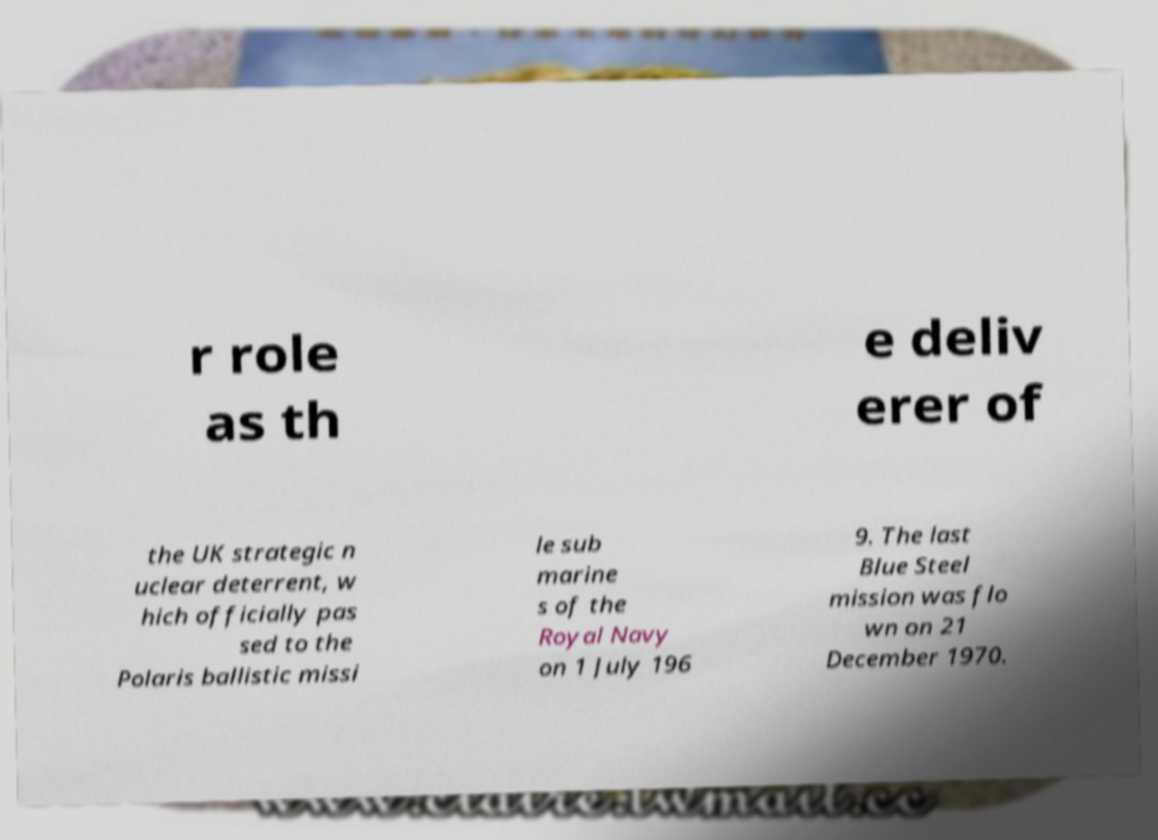Can you read and provide the text displayed in the image?This photo seems to have some interesting text. Can you extract and type it out for me? r role as th e deliv erer of the UK strategic n uclear deterrent, w hich officially pas sed to the Polaris ballistic missi le sub marine s of the Royal Navy on 1 July 196 9. The last Blue Steel mission was flo wn on 21 December 1970. 